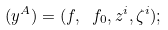<formula> <loc_0><loc_0><loc_500><loc_500>( y ^ { A } ) = ( f , \ f _ { 0 } , z ^ { i } , \zeta ^ { i } ) ;</formula> 